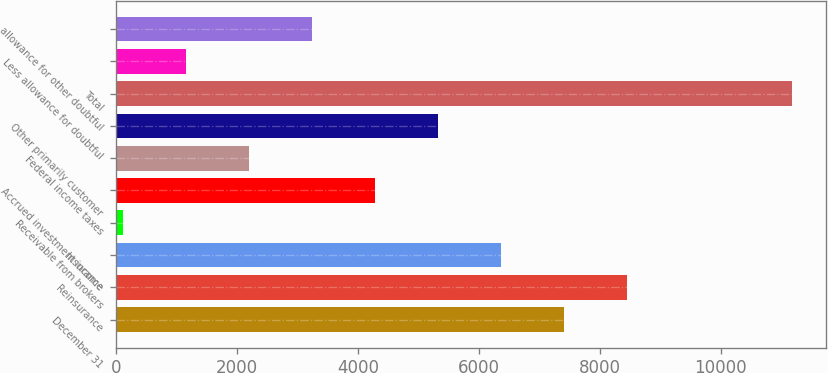Convert chart to OTSL. <chart><loc_0><loc_0><loc_500><loc_500><bar_chart><fcel>December 31<fcel>Reinsurance<fcel>Insurance<fcel>Receivable from brokers<fcel>Accrued investment income<fcel>Federal income taxes<fcel>Other primarily customer<fcel>Total<fcel>Less allowance for doubtful<fcel>allowance for other doubtful<nl><fcel>7413.1<fcel>8457.4<fcel>6368.8<fcel>103<fcel>4280.2<fcel>2191.6<fcel>5324.5<fcel>11186.3<fcel>1147.3<fcel>3235.9<nl></chart> 